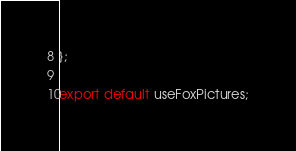Convert code to text. <code><loc_0><loc_0><loc_500><loc_500><_TypeScript_>};

export default useFoxPictures;
</code> 